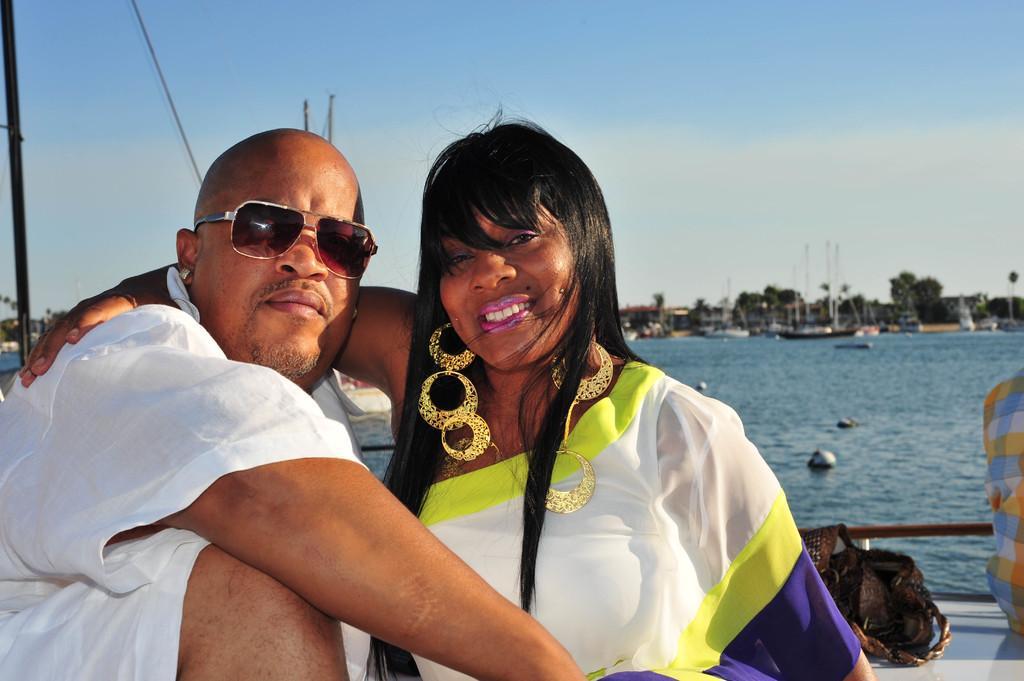In one or two sentences, can you explain what this image depicts? In this image we can see a sky. There are few water crafts in the image. There are few people sailing in the watercraft. There are few objects in the watercraft. There are many trees in the image. 